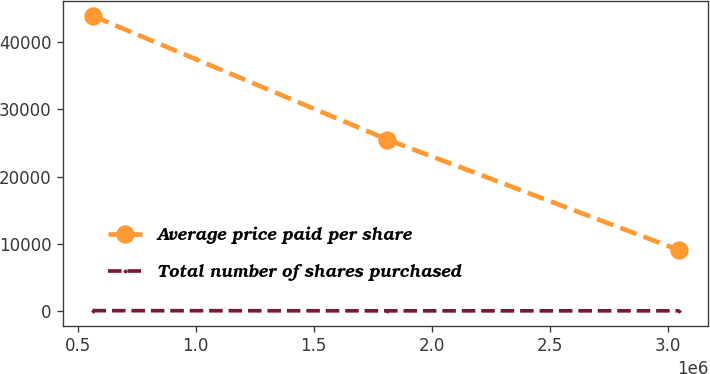Convert chart to OTSL. <chart><loc_0><loc_0><loc_500><loc_500><line_chart><ecel><fcel>Average price paid per share<fcel>Total number of shares purchased<nl><fcel>562735<fcel>43877.6<fcel>78.41<nl><fcel>1.81167e+06<fcel>25495.8<fcel>52.5<nl><fcel>3.047e+06<fcel>9080.7<fcel>55.09<nl></chart> 